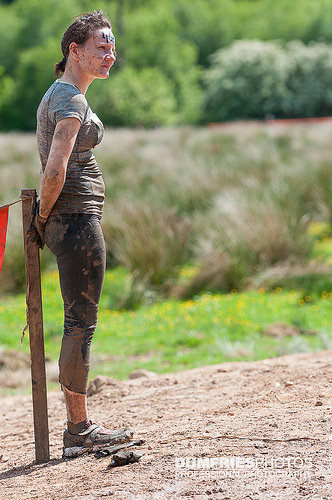<image>
Is there a tree behind the woman? Yes. From this viewpoint, the tree is positioned behind the woman, with the woman partially or fully occluding the tree. Is there a girl above the ground? No. The girl is not positioned above the ground. The vertical arrangement shows a different relationship. 